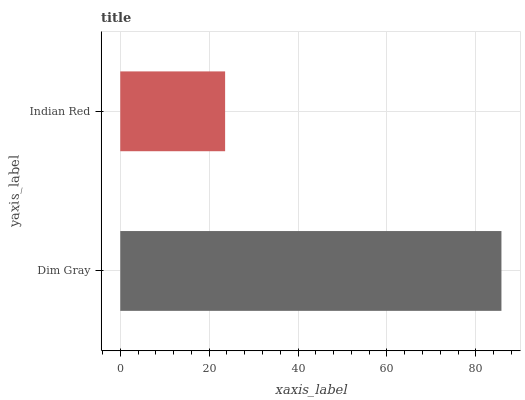Is Indian Red the minimum?
Answer yes or no. Yes. Is Dim Gray the maximum?
Answer yes or no. Yes. Is Indian Red the maximum?
Answer yes or no. No. Is Dim Gray greater than Indian Red?
Answer yes or no. Yes. Is Indian Red less than Dim Gray?
Answer yes or no. Yes. Is Indian Red greater than Dim Gray?
Answer yes or no. No. Is Dim Gray less than Indian Red?
Answer yes or no. No. Is Dim Gray the high median?
Answer yes or no. Yes. Is Indian Red the low median?
Answer yes or no. Yes. Is Indian Red the high median?
Answer yes or no. No. Is Dim Gray the low median?
Answer yes or no. No. 